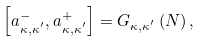Convert formula to latex. <formula><loc_0><loc_0><loc_500><loc_500>\left [ a _ { \kappa , \kappa ^ { ^ { \prime } } } ^ { - } , a _ { \kappa , \kappa ^ { ^ { \prime } } } ^ { + } \right ] = G _ { \kappa , \kappa ^ { ^ { \prime } } } \left ( N \right ) ,</formula> 